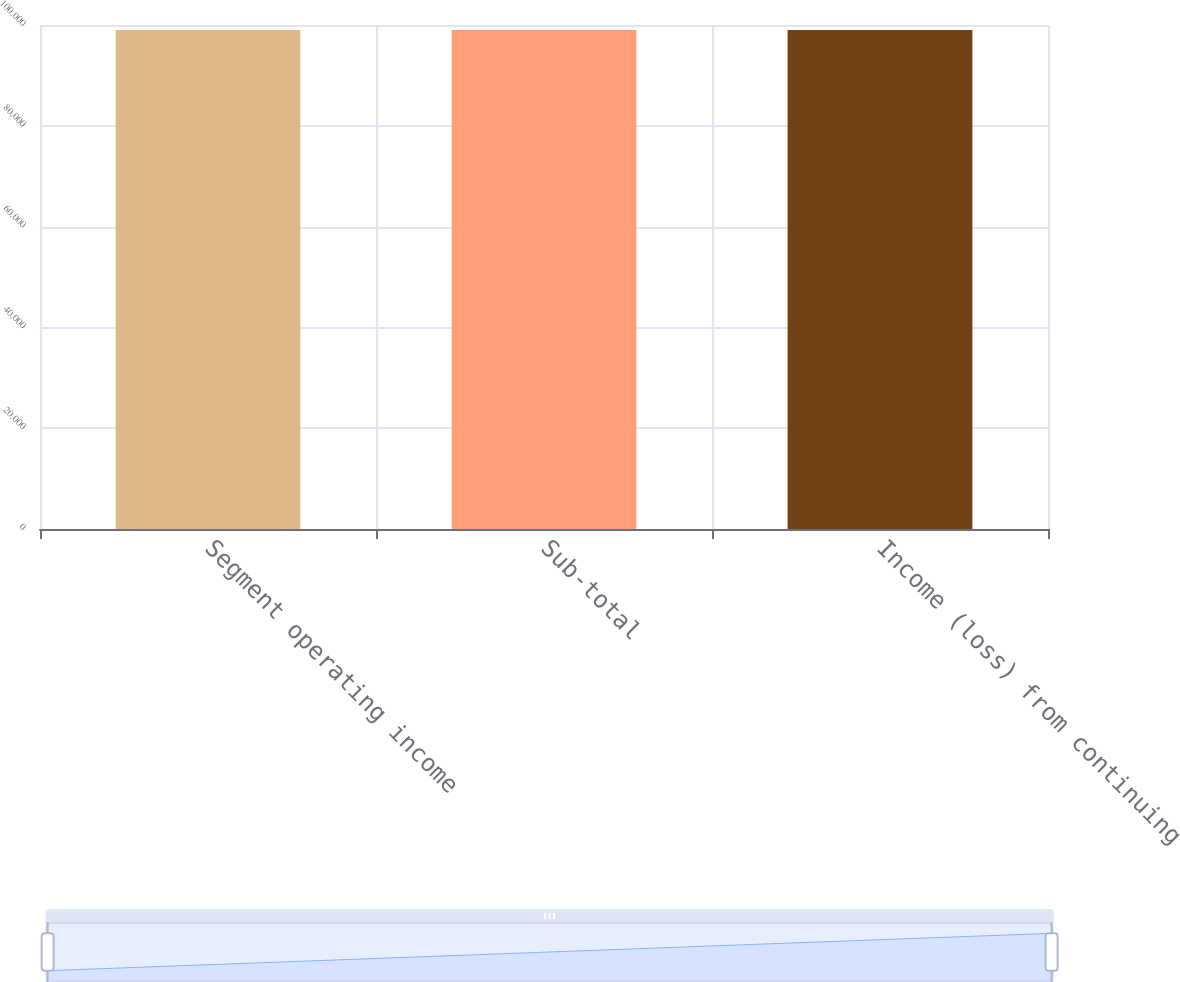<chart> <loc_0><loc_0><loc_500><loc_500><bar_chart><fcel>Segment operating income<fcel>Sub-total<fcel>Income (loss) from continuing<nl><fcel>99032<fcel>99032.1<fcel>99032.2<nl></chart> 